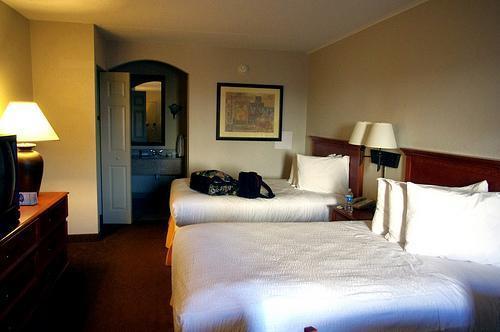How many beds are in the room?
Give a very brief answer. 2. 